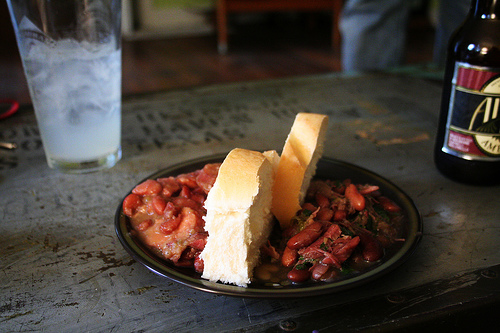<image>
Is the bottle next to the glass? Yes. The bottle is positioned adjacent to the glass, located nearby in the same general area. 